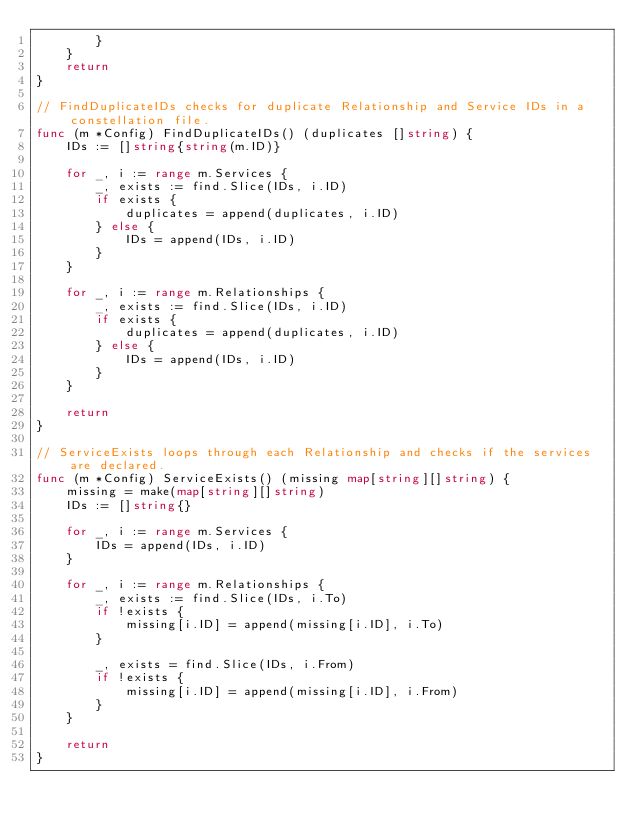<code> <loc_0><loc_0><loc_500><loc_500><_Go_>		}
	}
	return
}

// FindDuplicateIDs checks for duplicate Relationship and Service IDs in a constellation file.
func (m *Config) FindDuplicateIDs() (duplicates []string) {
	IDs := []string{string(m.ID)}

	for _, i := range m.Services {
		_, exists := find.Slice(IDs, i.ID)
		if exists {
			duplicates = append(duplicates, i.ID)
		} else {
			IDs = append(IDs, i.ID)
		}
	}

	for _, i := range m.Relationships {
		_, exists := find.Slice(IDs, i.ID)
		if exists {
			duplicates = append(duplicates, i.ID)
		} else {
			IDs = append(IDs, i.ID)
		}
	}

	return
}

// ServiceExists loops through each Relationship and checks if the services are declared.
func (m *Config) ServiceExists() (missing map[string][]string) {
	missing = make(map[string][]string)
	IDs := []string{}

	for _, i := range m.Services {
		IDs = append(IDs, i.ID)
	}

	for _, i := range m.Relationships {
		_, exists := find.Slice(IDs, i.To)
		if !exists {
			missing[i.ID] = append(missing[i.ID], i.To)
		}

		_, exists = find.Slice(IDs, i.From)
		if !exists {
			missing[i.ID] = append(missing[i.ID], i.From)
		}
	}

	return
}
</code> 